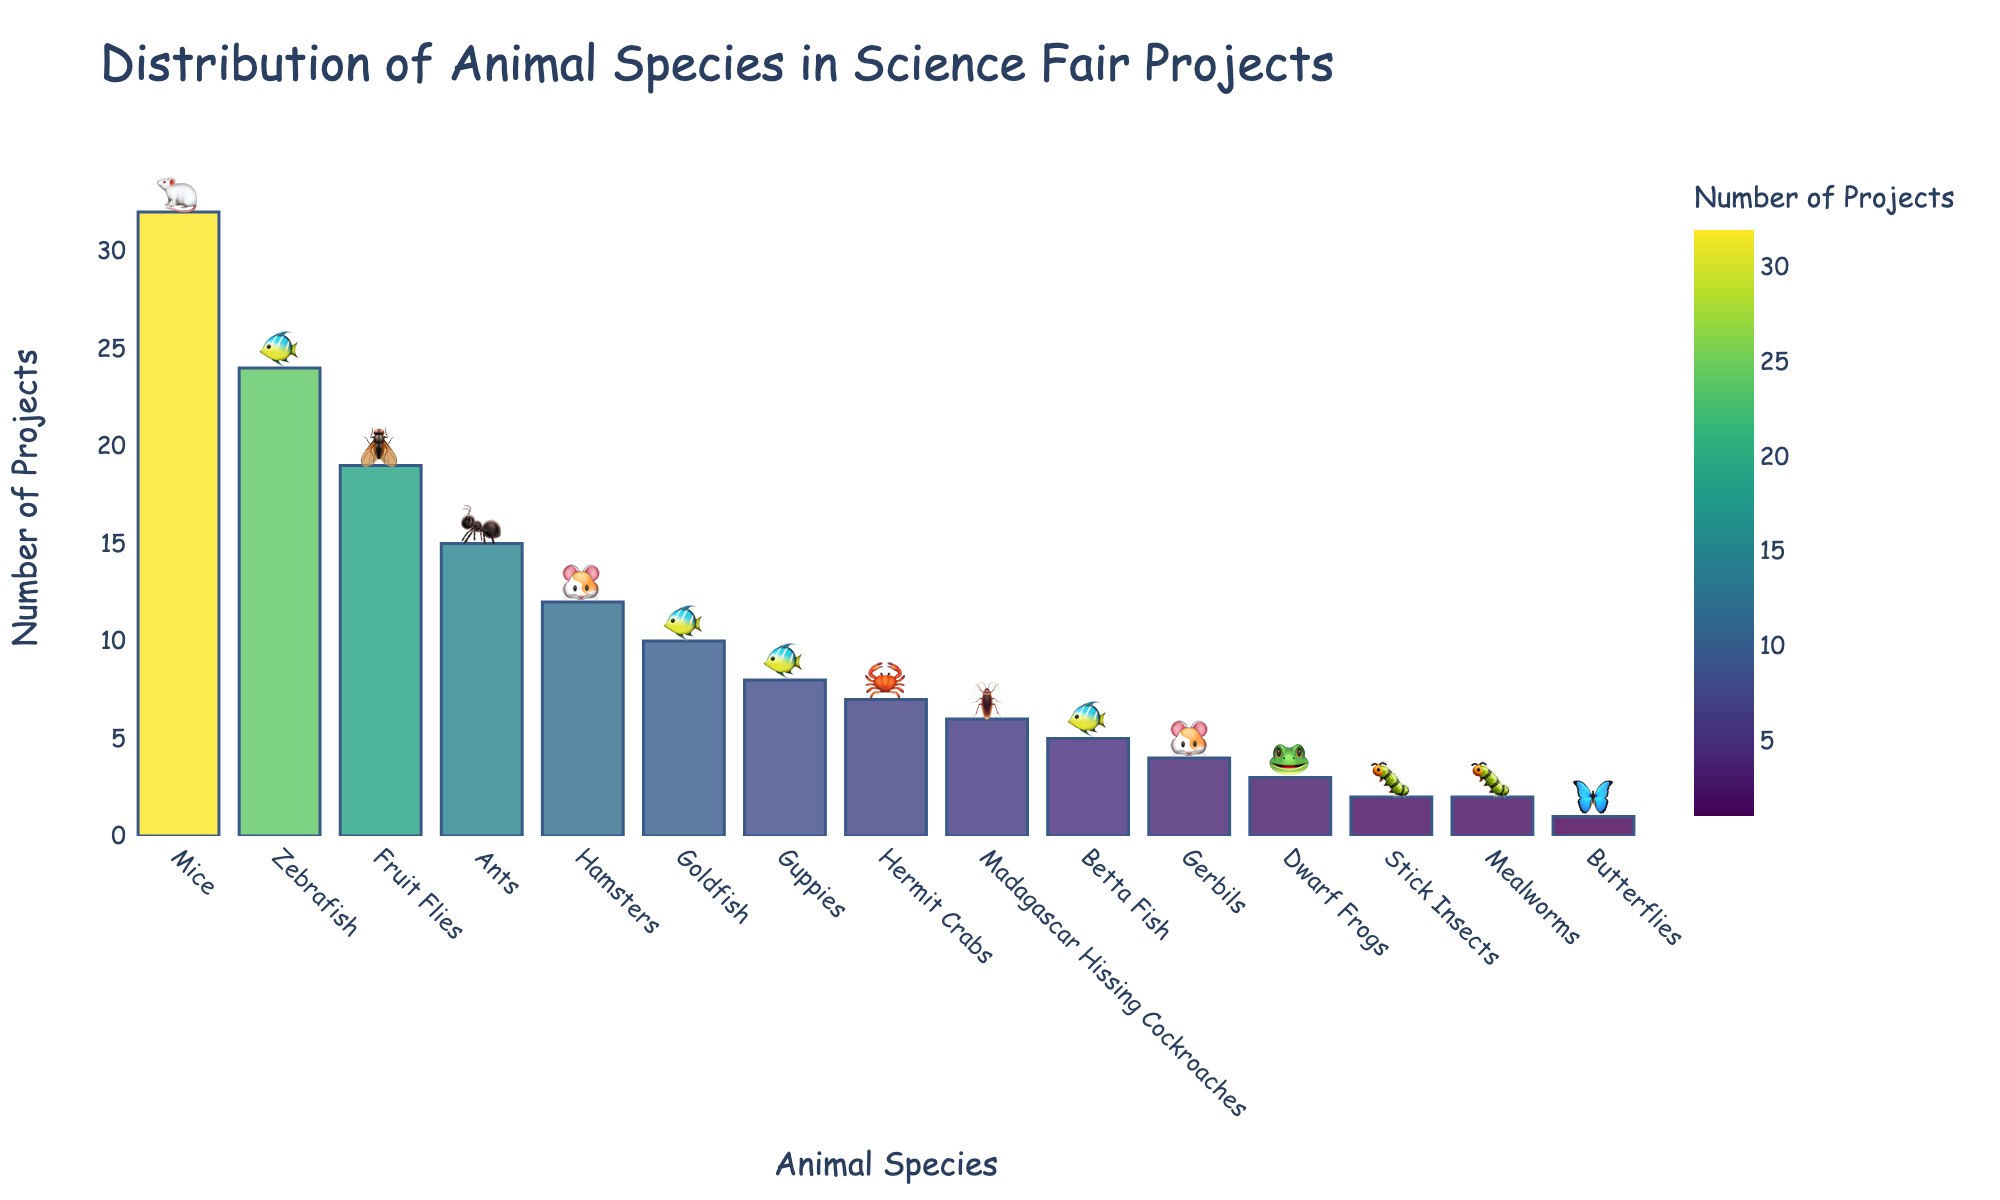Which animal species has the highest number of projects? The bar chart shows the number of projects for each animal species. The tallest bar corresponds to the animal species with the highest number of projects. Mice have the highest number of projects, according to the chart.
Answer: Mice What is the combined number of projects for Zebrafish and Fruit Flies? To find the combined number of projects, add the number of projects for Zebrafish and Fruit Flies together. According to the chart, Zebrafish has 24 projects and Fruit Flies have 19 projects. Therefore, the combined number is 24 + 19 = 43.
Answer: 43 How does the number of projects for Ants compare with Hamsters? Compare the heights of the bars for Ants and Hamsters. Ants have 15 projects while Hamsters have 12 projects. Therefore, Ants have more projects than Hamsters.
Answer: Ants have more Which animal species has the fewest number of projects, and how many does it have? The shortest bar in the chart represents the species with the fewest number of projects. Butterflies have the fewest number of projects with only 1 project.
Answer: Butterflies, 1 How many more projects do Mice have compared to Goldfish? To find how many more projects Mice have compared to Goldfish, subtract the number of projects for Goldfish from the number of projects for Mice. Mice have 32 projects, and Goldfish have 10 projects. Therefore, 32 - 10 = 22.
Answer: 22 What is the average number of projects for the species listed (rounded to the nearest whole number)? To find the average number of projects, sum the number of projects for all species and then divide by the number of species. The total number of projects is 151, and there are 15 species. Therefore, the average is 151 / 15 ≈ 10.
Answer: 10 Which color predominates in the chart for the most frequently used animals in projects? Look at the color of the bars for the animal species with the highest number of projects. The bars follow a color scale from Viridis, with the predominant color for Mice, which have the most projects, being a shade of yellow-green.
Answer: Yellow-green What are the total number of projects for animal species that have fewer than 10 projects each? Sum the number of projects for species with fewer than 10 projects. These species and their respective project numbers are Guppies (8), Hermit Crabs (7), Madagascar Hissing Cockroaches (6), Betta Fish (5), Gerbils (4), Dwarf Frogs (3), Stick Insects (2), Mealworms (2), and Butterflies (1). Their total is 8 + 7 + 6 + 5 + 4 + 3 + 2 + 2 + 1 = 38.
Answer: 38 